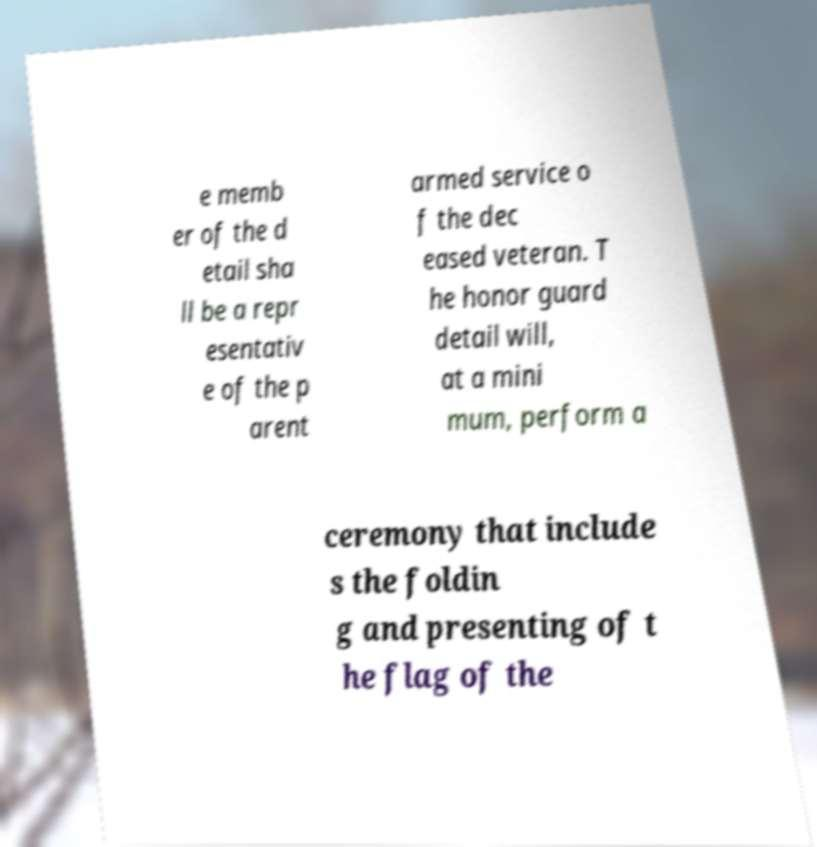Could you extract and type out the text from this image? e memb er of the d etail sha ll be a repr esentativ e of the p arent armed service o f the dec eased veteran. T he honor guard detail will, at a mini mum, perform a ceremony that include s the foldin g and presenting of t he flag of the 